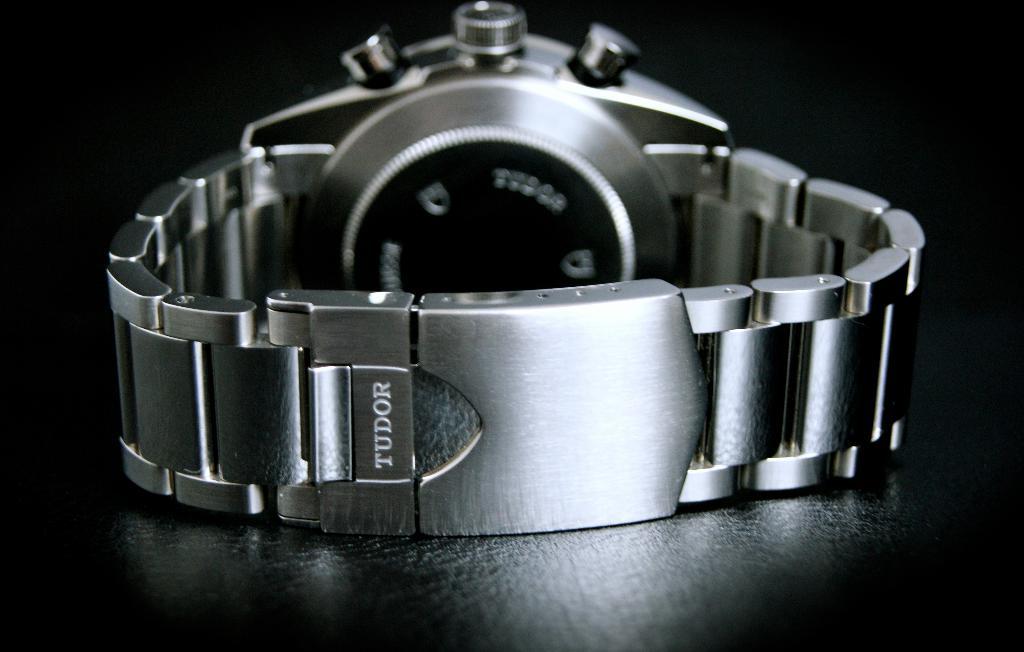What brand of watch is this?
Keep it short and to the point. Tudor. 